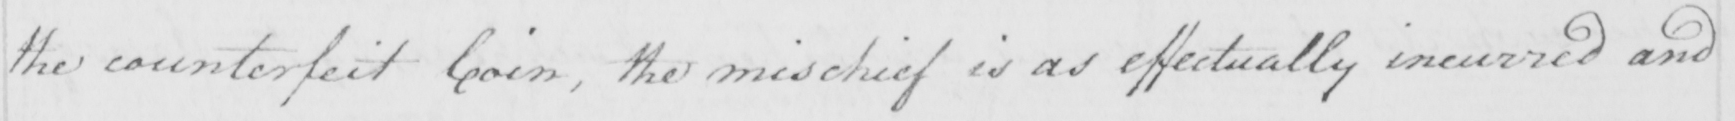What text is written in this handwritten line? the counterfeit Coin , the mischief is as effectually incurred and 